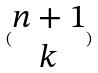<formula> <loc_0><loc_0><loc_500><loc_500>( \begin{matrix} n + 1 \\ k \end{matrix} )</formula> 